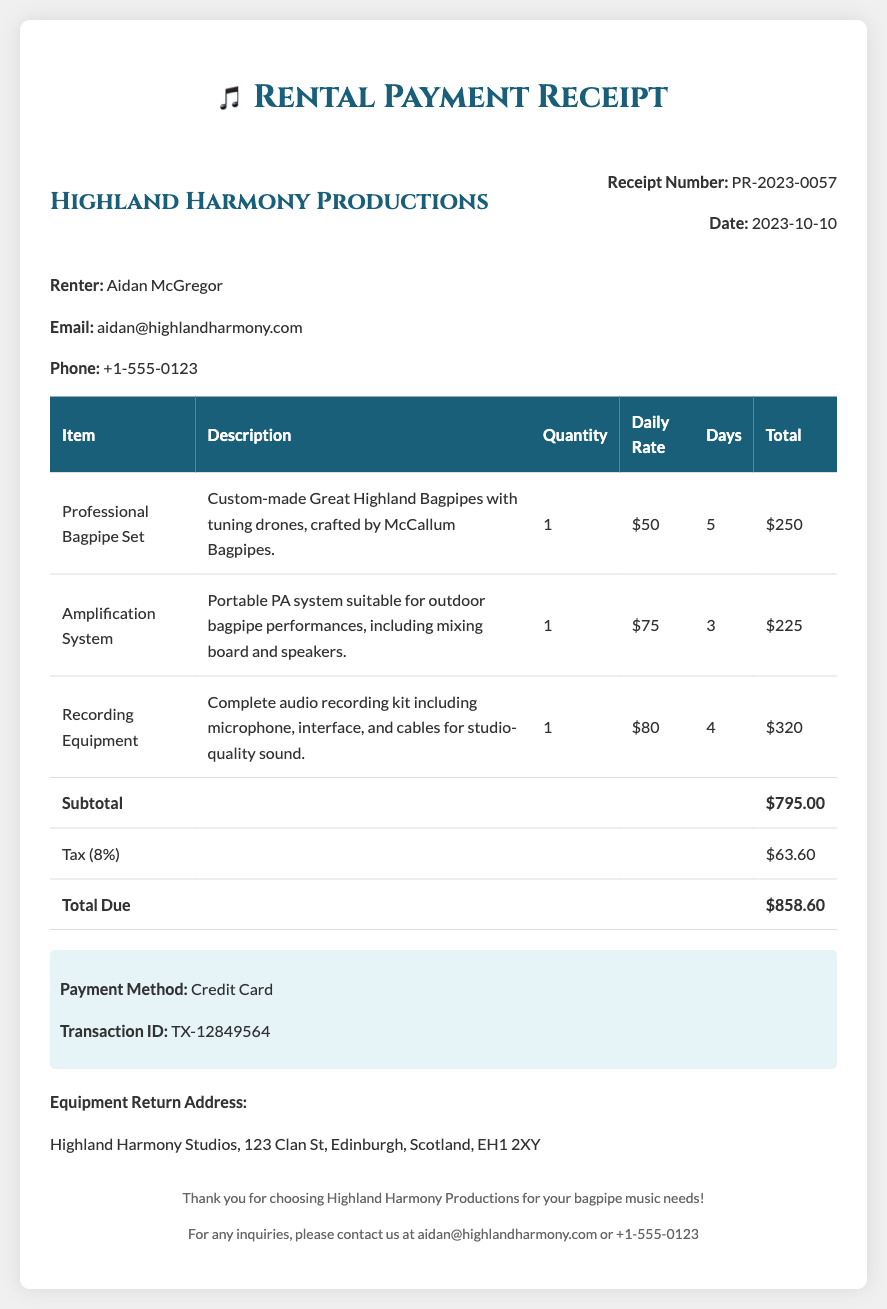What is the receipt number? The receipt number is listed under the receipt information section.
Answer: PR-2023-0057 What is the date of the receipt? The date is specified next to the receipt number in the top header of the document.
Answer: 2023-10-10 Who is the renter? The renter's name is mentioned in the renter info section of the document.
Answer: Aidan McGregor What items were rented? The items rented are listed in the table under the item column.
Answer: Professional Bagpipe Set, Amplification System, Recording Equipment What is the total amount due? The total amount due is calculated from the subtotal and tax in the last rows of the table.
Answer: $858.60 How many days was the Professional Bagpipe Set rented? The rental duration for each item is shown in the table for each specific item.
Answer: 5 What is the tax percentage applied? The tax percentage is mentioned in the table while calculating the total amount.
Answer: 8% What payment method was used? The payment method used is stated in the payment method section of the document.
Answer: Credit Card What is the equipment return address? The return address is specified in the return information section of the document.
Answer: Highland Harmony Studios, 123 Clan St, Edinburgh, Scotland, EH1 2XY 